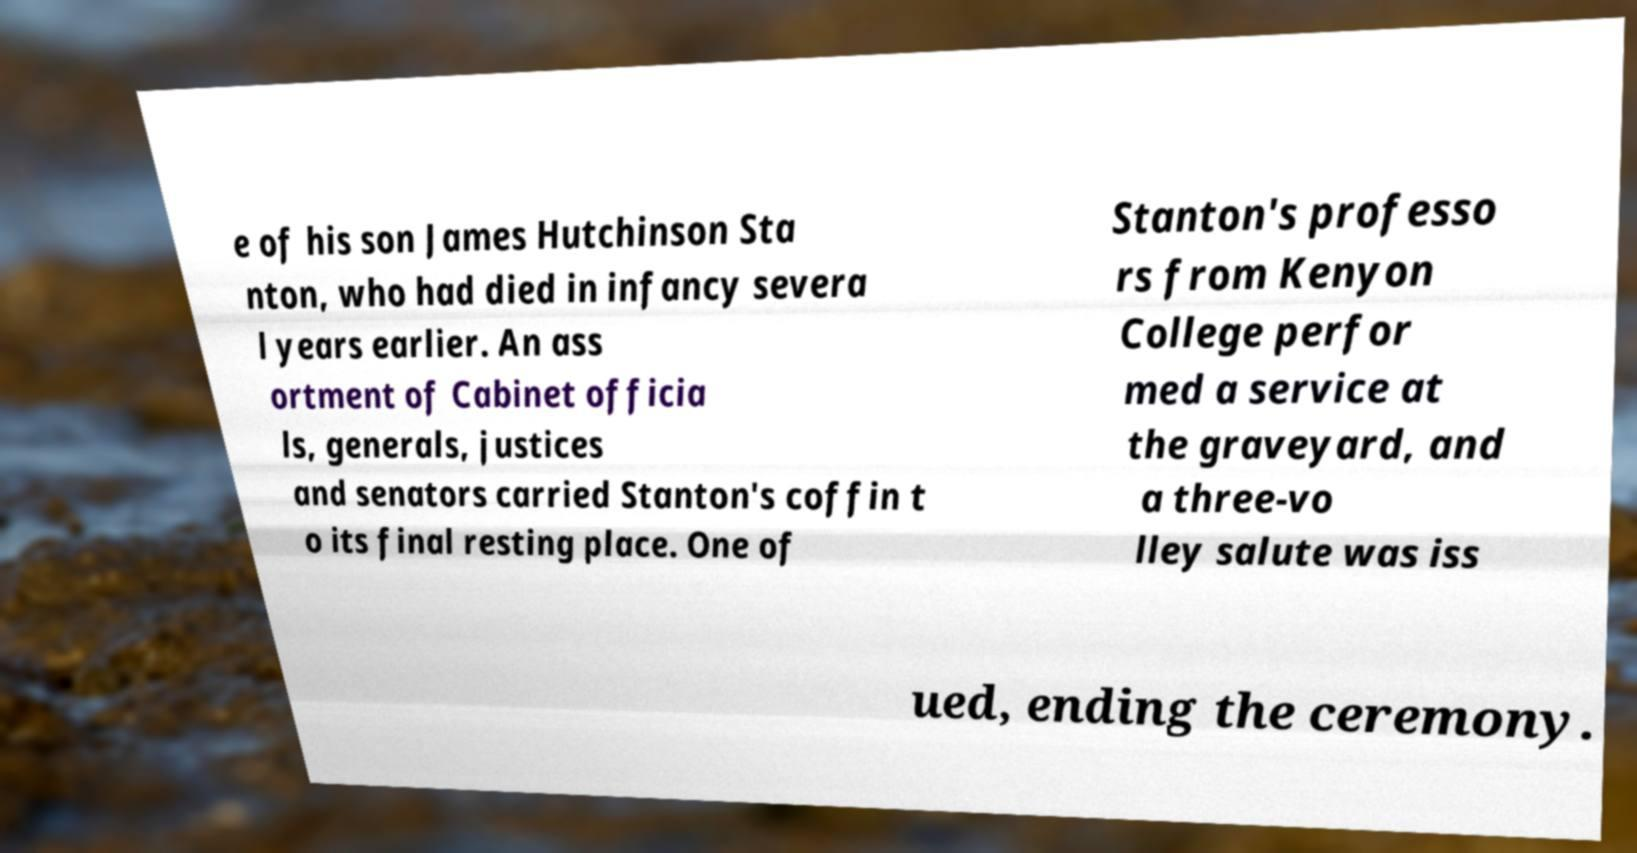Could you assist in decoding the text presented in this image and type it out clearly? e of his son James Hutchinson Sta nton, who had died in infancy severa l years earlier. An ass ortment of Cabinet officia ls, generals, justices and senators carried Stanton's coffin t o its final resting place. One of Stanton's professo rs from Kenyon College perfor med a service at the graveyard, and a three-vo lley salute was iss ued, ending the ceremony. 